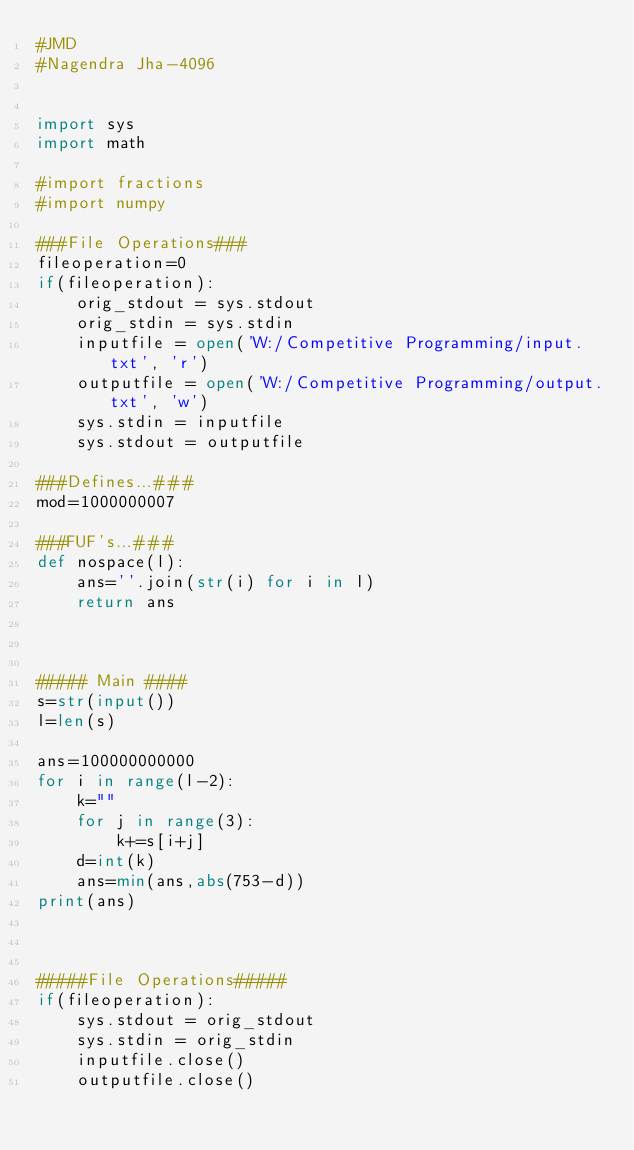Convert code to text. <code><loc_0><loc_0><loc_500><loc_500><_Python_>#JMD
#Nagendra Jha-4096

 
import sys
import math

#import fractions
#import numpy
 
###File Operations###
fileoperation=0
if(fileoperation):
    orig_stdout = sys.stdout
    orig_stdin = sys.stdin
    inputfile = open('W:/Competitive Programming/input.txt', 'r')
    outputfile = open('W:/Competitive Programming/output.txt', 'w')
    sys.stdin = inputfile
    sys.stdout = outputfile

###Defines...###
mod=1000000007
 
###FUF's...###
def nospace(l):
    ans=''.join(str(i) for i in l)
    return ans
 
 
 
##### Main ####
s=str(input())
l=len(s)

ans=100000000000
for i in range(l-2):
    k=""
    for j in range(3):
        k+=s[i+j]
    d=int(k)
    ans=min(ans,abs(753-d))
print(ans)

    
    
#####File Operations#####
if(fileoperation):
    sys.stdout = orig_stdout
    sys.stdin = orig_stdin
    inputfile.close()
    outputfile.close()</code> 